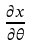<formula> <loc_0><loc_0><loc_500><loc_500>\frac { \partial x } { \partial \theta }</formula> 